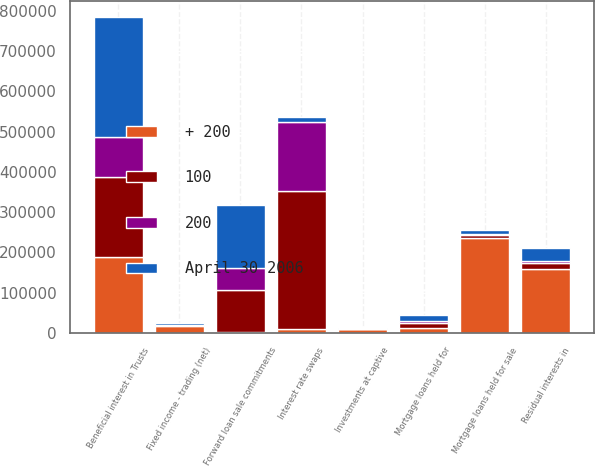<chart> <loc_0><loc_0><loc_500><loc_500><stacked_bar_chart><ecel><fcel>Mortgage loans held for<fcel>Mortgage loans held for sale<fcel>Beneficial interest in Trusts<fcel>Residual interests in<fcel>Fixed income - trading (net)<fcel>Interest rate swaps<fcel>Investments at captive<fcel>Forward loan sale commitments<nl><fcel>+ 200<fcel>12214<fcel>236399<fcel>188014<fcel>159058<fcel>15609<fcel>8831<fcel>8508<fcel>1961<nl><fcel>April 30 2006<fcel>16285<fcel>9253<fcel>298013<fcel>32692<fcel>4323<fcel>12214<fcel>1260<fcel>158345<nl><fcel>100<fcel>10885<fcel>6113<fcel>199029<fcel>13543<fcel>2617<fcel>344606<fcel>814<fcel>105563<nl><fcel>200<fcel>5485<fcel>3057<fcel>100039<fcel>4795<fcel>1174<fcel>170090<fcel>395<fcel>52782<nl></chart> 